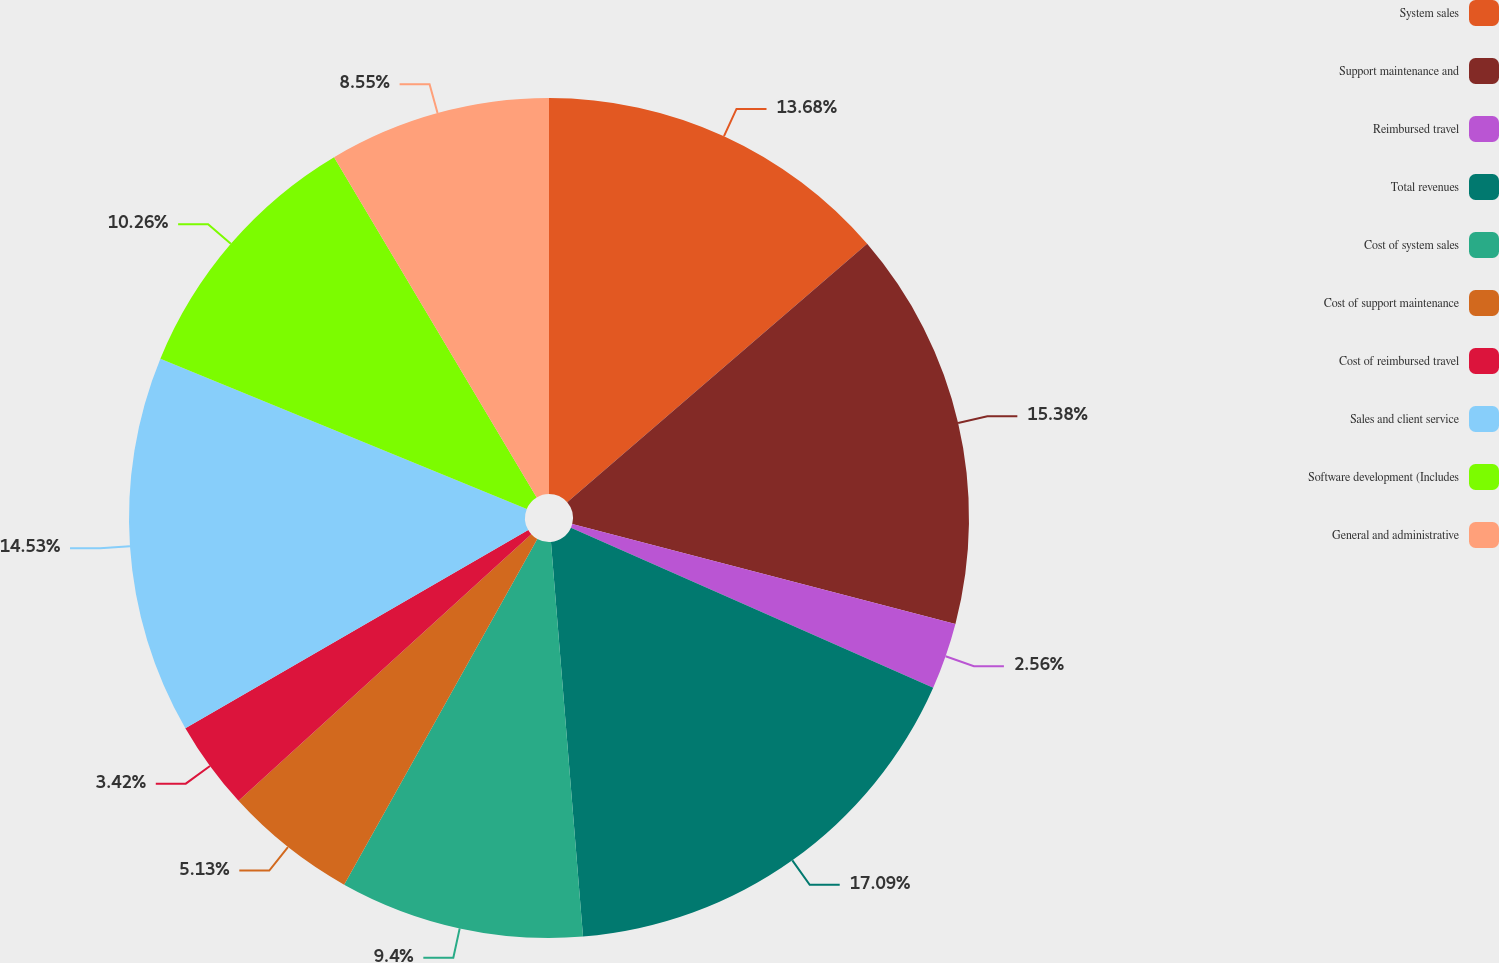Convert chart. <chart><loc_0><loc_0><loc_500><loc_500><pie_chart><fcel>System sales<fcel>Support maintenance and<fcel>Reimbursed travel<fcel>Total revenues<fcel>Cost of system sales<fcel>Cost of support maintenance<fcel>Cost of reimbursed travel<fcel>Sales and client service<fcel>Software development (Includes<fcel>General and administrative<nl><fcel>13.68%<fcel>15.38%<fcel>2.56%<fcel>17.09%<fcel>9.4%<fcel>5.13%<fcel>3.42%<fcel>14.53%<fcel>10.26%<fcel>8.55%<nl></chart> 